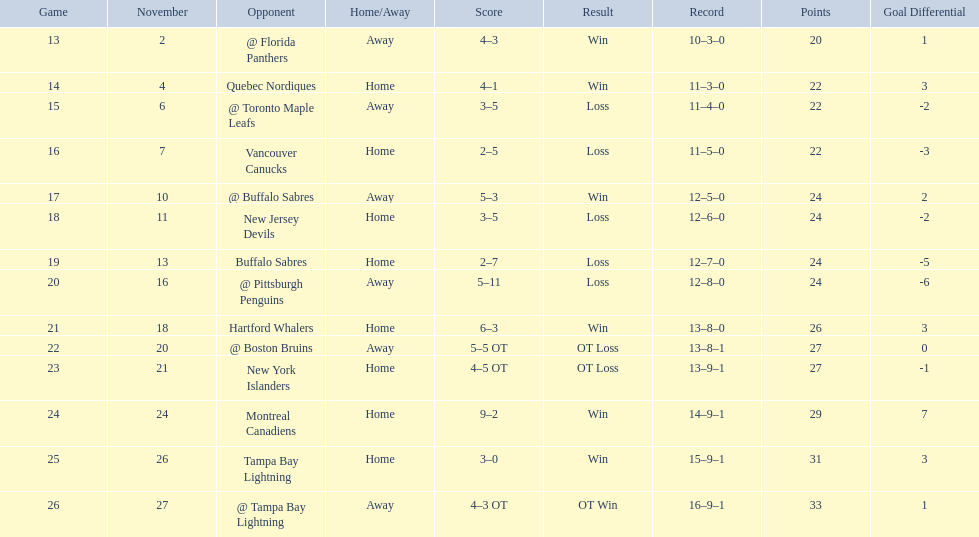What were the scores? @ Florida Panthers, 4–3, Quebec Nordiques, 4–1, @ Toronto Maple Leafs, 3–5, Vancouver Canucks, 2–5, @ Buffalo Sabres, 5–3, New Jersey Devils, 3–5, Buffalo Sabres, 2–7, @ Pittsburgh Penguins, 5–11, Hartford Whalers, 6–3, @ Boston Bruins, 5–5 OT, New York Islanders, 4–5 OT, Montreal Canadiens, 9–2, Tampa Bay Lightning, 3–0, @ Tampa Bay Lightning, 4–3 OT. What score was the closest? New York Islanders, 4–5 OT. What team had that score? New York Islanders. 